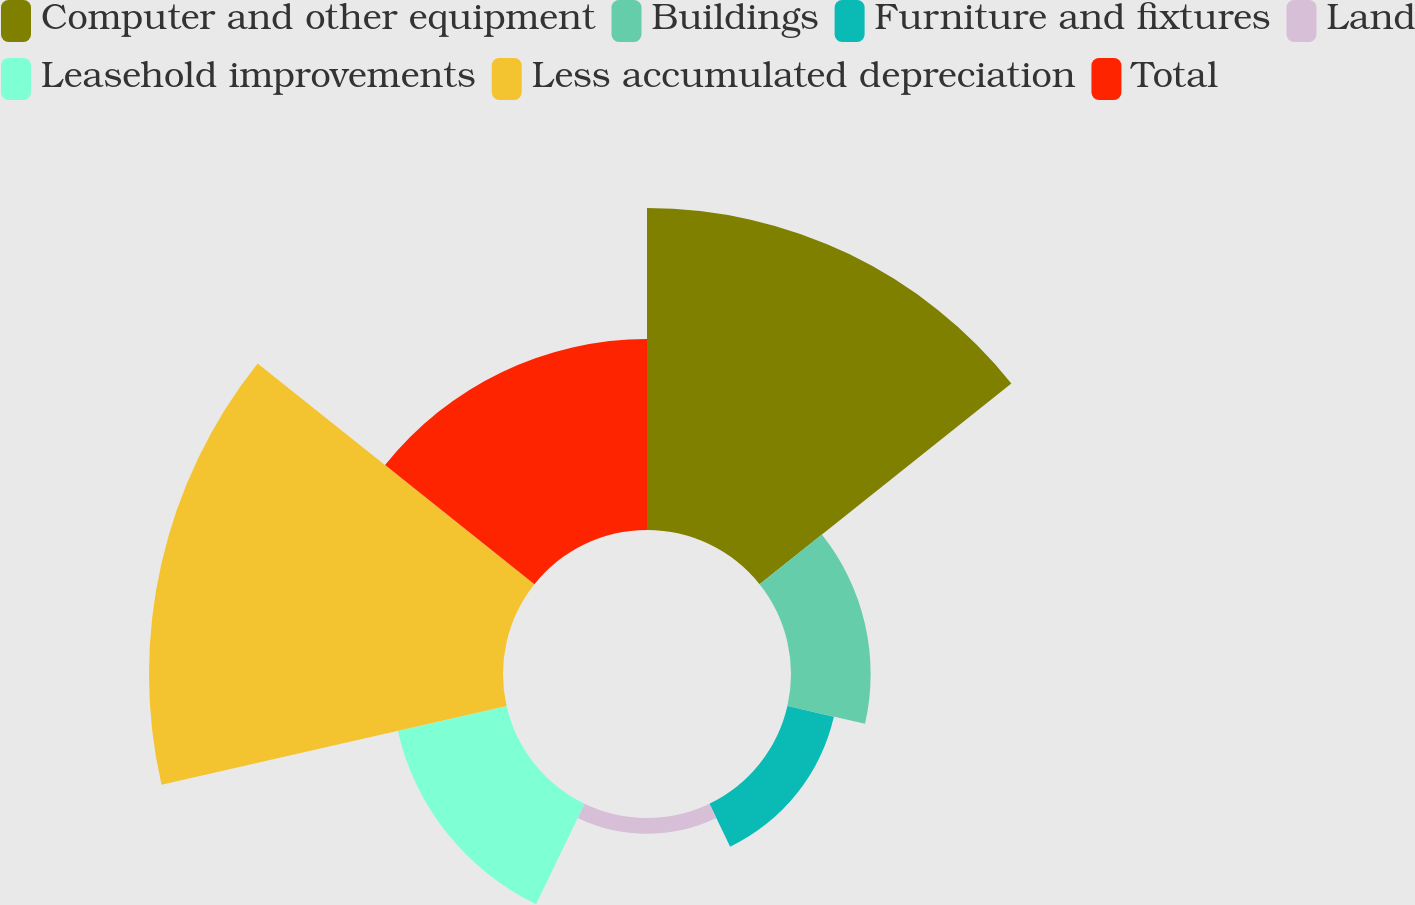<chart> <loc_0><loc_0><loc_500><loc_500><pie_chart><fcel>Computer and other equipment<fcel>Buildings<fcel>Furniture and fixtures<fcel>Land<fcel>Leasehold improvements<fcel>Less accumulated depreciation<fcel>Total<nl><fcel>28.71%<fcel>7.1%<fcel>4.25%<fcel>1.4%<fcel>9.95%<fcel>31.56%<fcel>17.03%<nl></chart> 